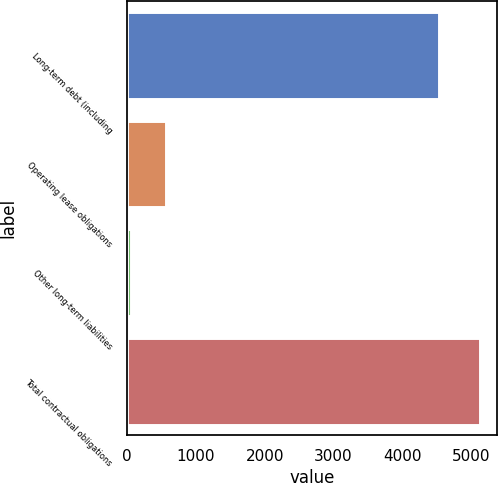Convert chart to OTSL. <chart><loc_0><loc_0><loc_500><loc_500><bar_chart><fcel>Long-term debt (including<fcel>Operating lease obligations<fcel>Other long-term liabilities<fcel>Total contractual obligations<nl><fcel>4536<fcel>566.1<fcel>60<fcel>5121<nl></chart> 